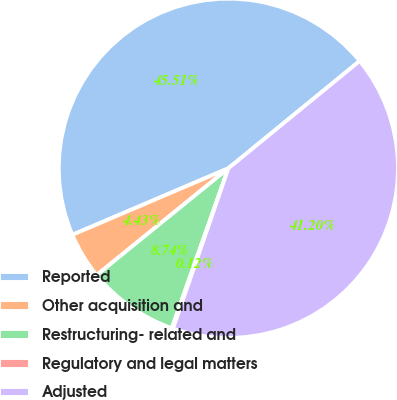<chart> <loc_0><loc_0><loc_500><loc_500><pie_chart><fcel>Reported<fcel>Other acquisition and<fcel>Restructuring- related and<fcel>Regulatory and legal matters<fcel>Adjusted<nl><fcel>45.51%<fcel>4.43%<fcel>8.74%<fcel>0.12%<fcel>41.2%<nl></chart> 